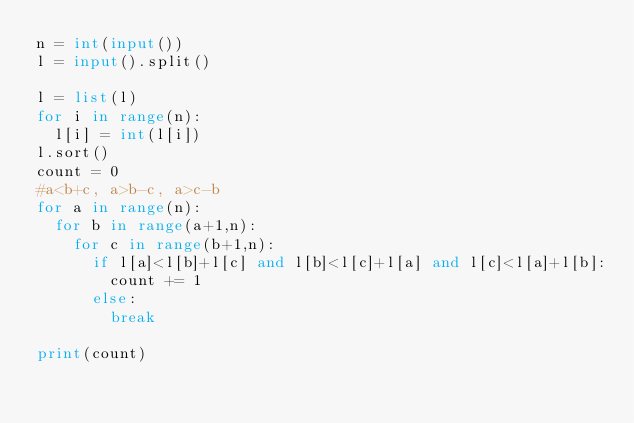<code> <loc_0><loc_0><loc_500><loc_500><_Python_>n = int(input())
l = input().split()

l = list(l)
for i in range(n):
	l[i] = int(l[i])
l.sort()
count = 0
#a<b+c, a>b-c, a>c-b
for a in range(n):
	for b in range(a+1,n):
		for c in range(b+1,n):
			if l[a]<l[b]+l[c] and l[b]<l[c]+l[a] and l[c]<l[a]+l[b]:
				count += 1
			else:
				break

print(count)</code> 